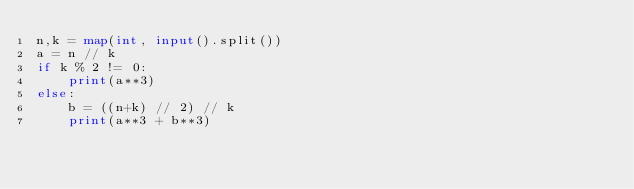<code> <loc_0><loc_0><loc_500><loc_500><_Python_>n,k = map(int, input().split())
a = n // k
if k % 2 != 0:
    print(a**3)
else:
    b = ((n+k) // 2) // k
    print(a**3 + b**3)</code> 